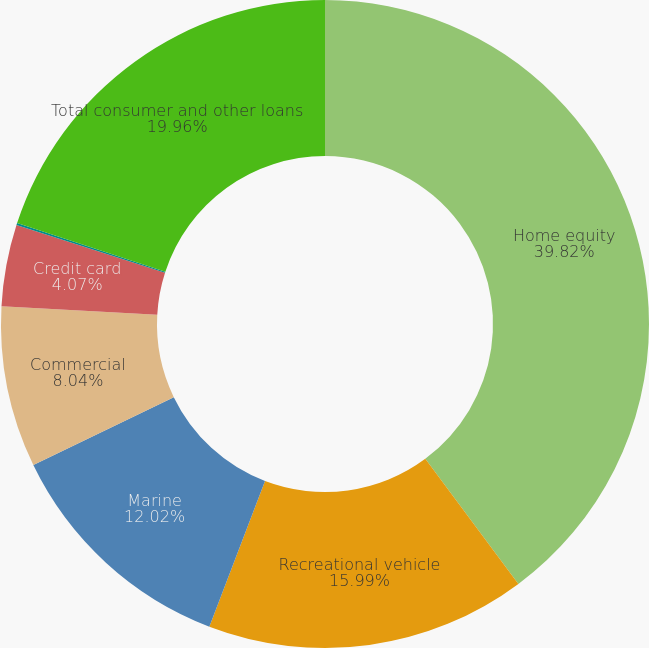Convert chart. <chart><loc_0><loc_0><loc_500><loc_500><pie_chart><fcel>Home equity<fcel>Recreational vehicle<fcel>Marine<fcel>Commercial<fcel>Credit card<fcel>Other<fcel>Total consumer and other loans<nl><fcel>39.82%<fcel>15.99%<fcel>12.02%<fcel>8.04%<fcel>4.07%<fcel>0.1%<fcel>19.96%<nl></chart> 